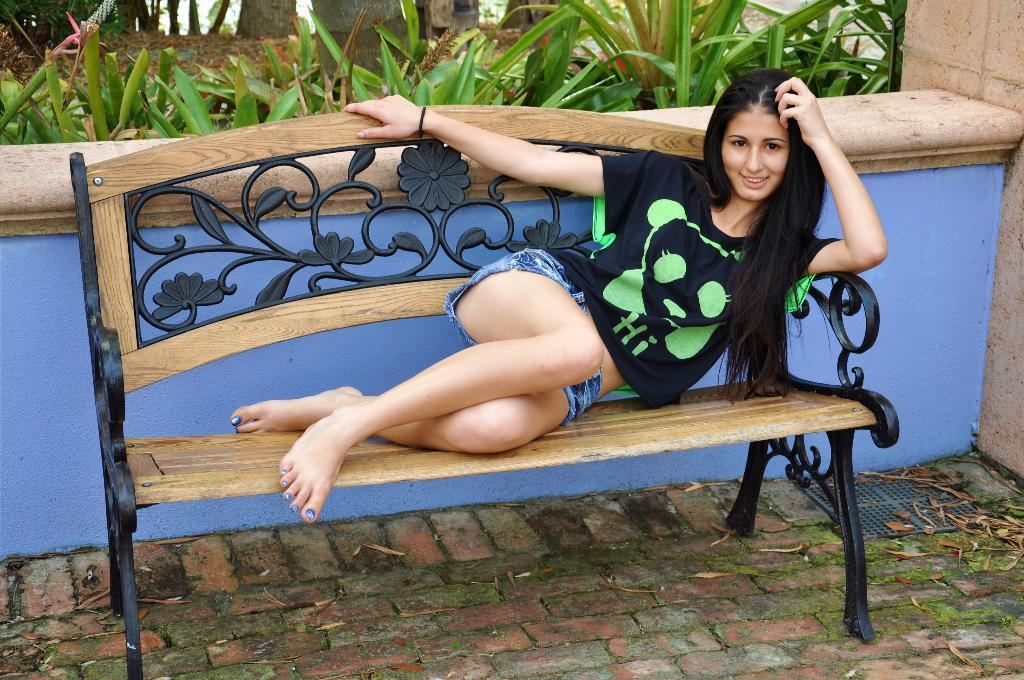Who is in the image? There is a woman in the image. What is the woman wearing? The woman is wearing a black t-shirt. What is the woman doing in the image? The woman is lying on a bench. What expression does the woman have? The woman is smiling. What can be seen in the background of the image? There is a blue wall and many plants in the garden in the background. What is the purpose of the door in the image? There is no door present in the image. How many oranges are visible in the image? There are no oranges present in the image. 